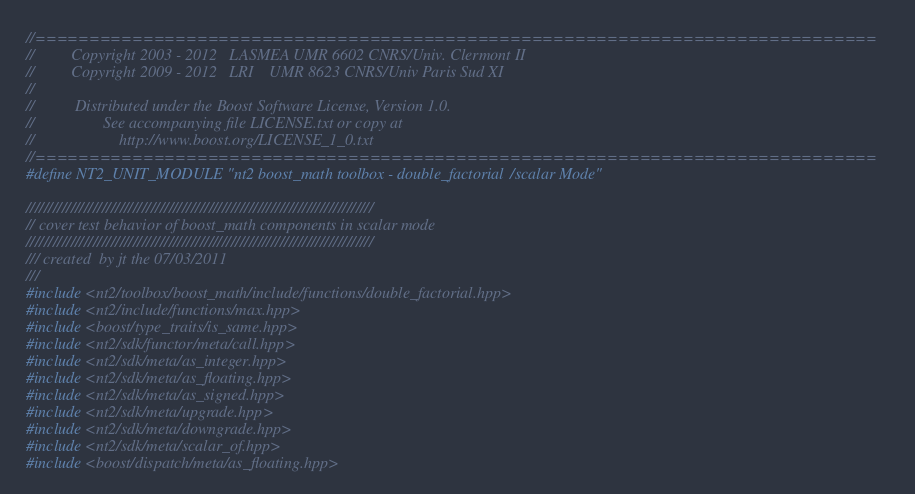Convert code to text. <code><loc_0><loc_0><loc_500><loc_500><_C++_>//==============================================================================
//         Copyright 2003 - 2012   LASMEA UMR 6602 CNRS/Univ. Clermont II
//         Copyright 2009 - 2012   LRI    UMR 8623 CNRS/Univ Paris Sud XI
//
//          Distributed under the Boost Software License, Version 1.0.
//                 See accompanying file LICENSE.txt or copy at
//                     http://www.boost.org/LICENSE_1_0.txt
//==============================================================================
#define NT2_UNIT_MODULE "nt2 boost_math toolbox - double_factorial/scalar Mode"

//////////////////////////////////////////////////////////////////////////////
// cover test behavior of boost_math components in scalar mode
//////////////////////////////////////////////////////////////////////////////
/// created  by jt the 07/03/2011
///
#include <nt2/toolbox/boost_math/include/functions/double_factorial.hpp>
#include <nt2/include/functions/max.hpp>
#include <boost/type_traits/is_same.hpp>
#include <nt2/sdk/functor/meta/call.hpp>
#include <nt2/sdk/meta/as_integer.hpp>
#include <nt2/sdk/meta/as_floating.hpp>
#include <nt2/sdk/meta/as_signed.hpp>
#include <nt2/sdk/meta/upgrade.hpp>
#include <nt2/sdk/meta/downgrade.hpp>
#include <nt2/sdk/meta/scalar_of.hpp>
#include <boost/dispatch/meta/as_floating.hpp></code> 